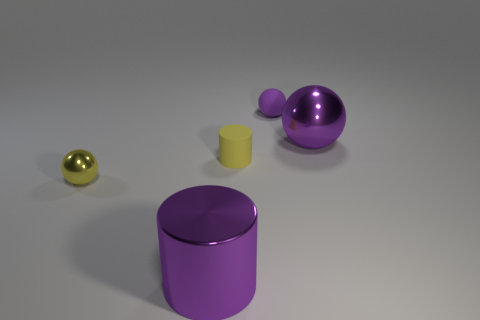Subtract all large metal spheres. How many spheres are left? 2 Subtract all yellow balls. How many balls are left? 2 Subtract 1 balls. How many balls are left? 2 Subtract all balls. How many objects are left? 2 Add 3 yellow shiny balls. How many objects exist? 8 Subtract all brown balls. How many yellow cylinders are left? 1 Subtract all large rubber cylinders. Subtract all small rubber things. How many objects are left? 3 Add 3 small spheres. How many small spheres are left? 5 Add 3 tiny green matte things. How many tiny green matte things exist? 3 Subtract 0 red spheres. How many objects are left? 5 